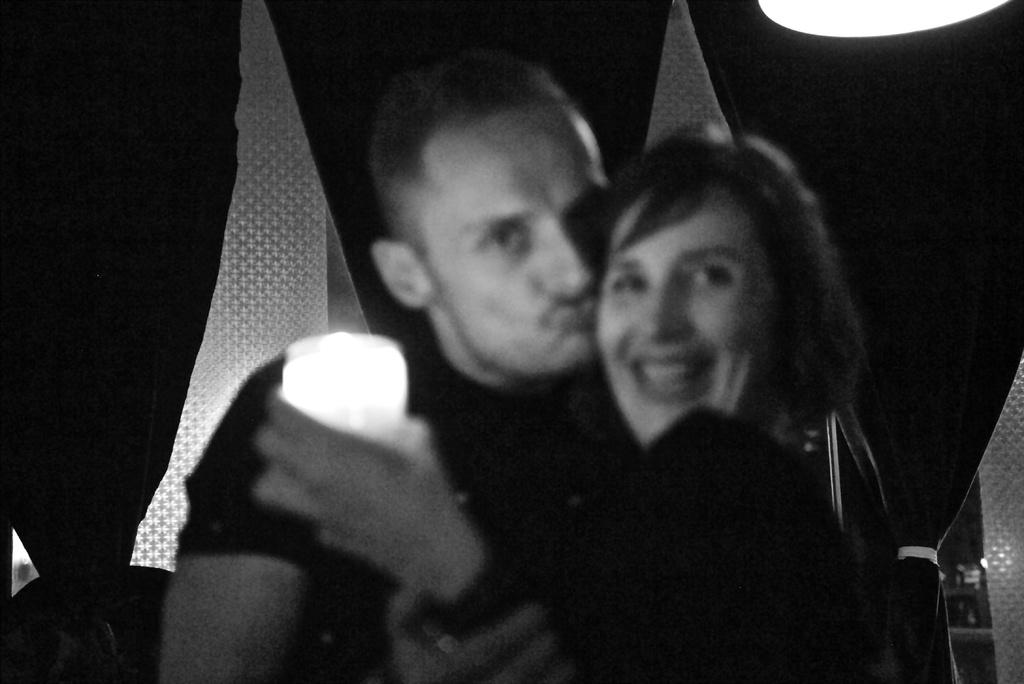What is happening between the person and the woman in the image? There is a person kissing a woman in the image. What is the woman holding in her hand? The woman is holding an object in the image. What can be seen in the background of the image? There are flags visible in the background of the image. What is the source of light at the top of the image? There is a light at the top of the image. What type of screw can be seen holding the wire in the image? There is no screw or wire present in the image. What news story is being discussed by the people in the image? There is no indication of a news story or discussion in the image. 